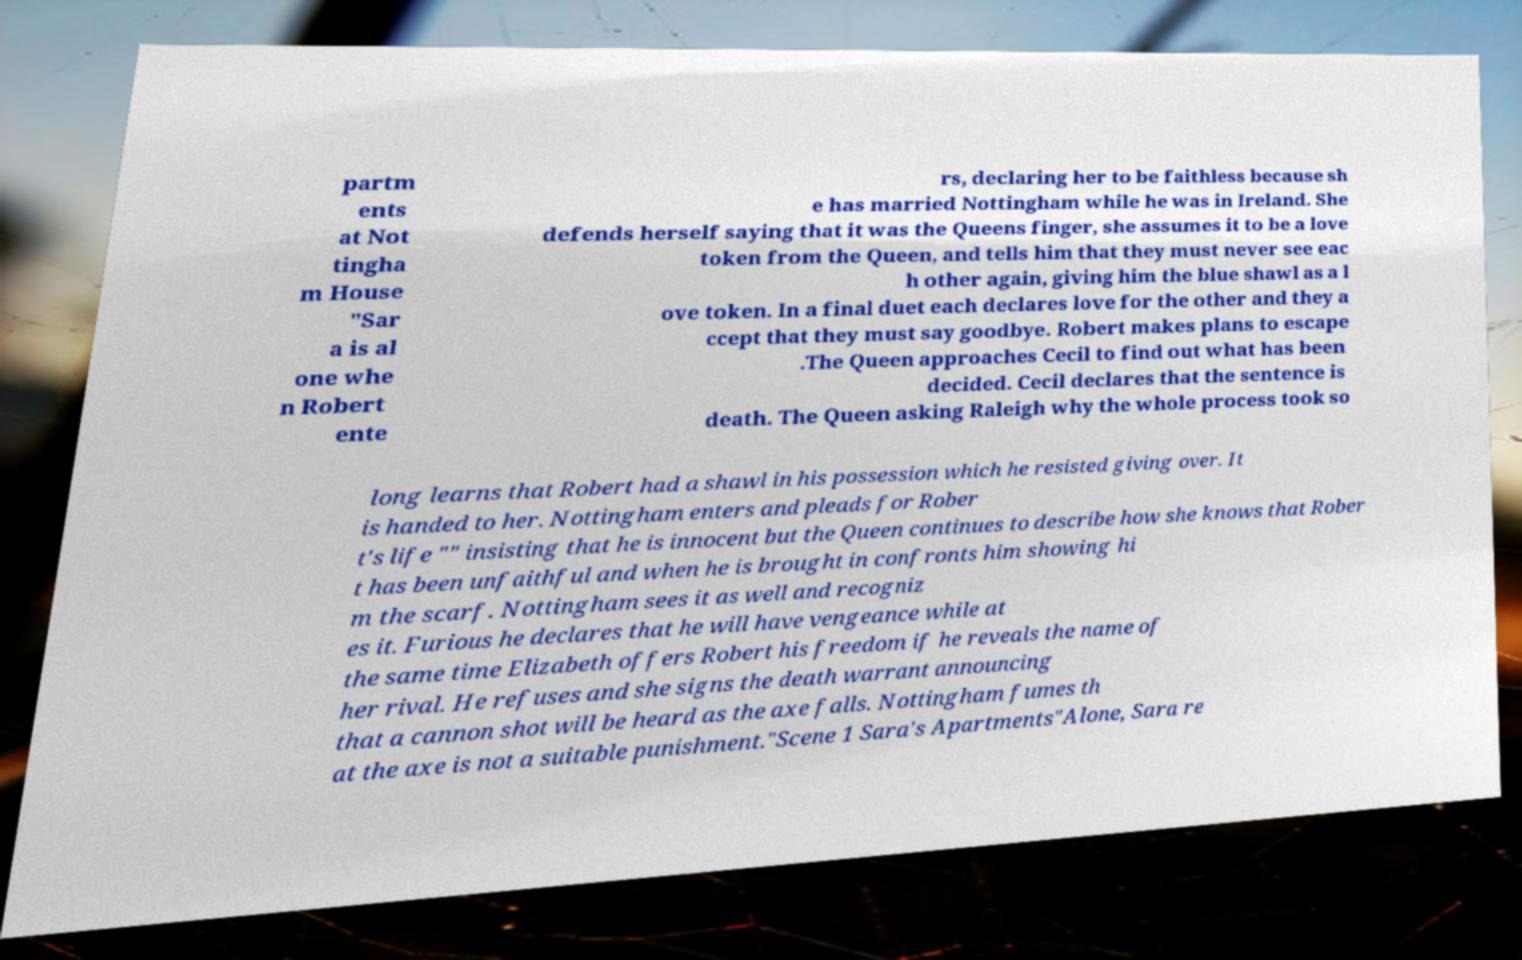Can you read and provide the text displayed in the image?This photo seems to have some interesting text. Can you extract and type it out for me? partm ents at Not tingha m House "Sar a is al one whe n Robert ente rs, declaring her to be faithless because sh e has married Nottingham while he was in Ireland. She defends herself saying that it was the Queens finger, she assumes it to be a love token from the Queen, and tells him that they must never see eac h other again, giving him the blue shawl as a l ove token. In a final duet each declares love for the other and they a ccept that they must say goodbye. Robert makes plans to escape .The Queen approaches Cecil to find out what has been decided. Cecil declares that the sentence is death. The Queen asking Raleigh why the whole process took so long learns that Robert had a shawl in his possession which he resisted giving over. It is handed to her. Nottingham enters and pleads for Rober t's life "" insisting that he is innocent but the Queen continues to describe how she knows that Rober t has been unfaithful and when he is brought in confronts him showing hi m the scarf. Nottingham sees it as well and recogniz es it. Furious he declares that he will have vengeance while at the same time Elizabeth offers Robert his freedom if he reveals the name of her rival. He refuses and she signs the death warrant announcing that a cannon shot will be heard as the axe falls. Nottingham fumes th at the axe is not a suitable punishment."Scene 1 Sara's Apartments"Alone, Sara re 